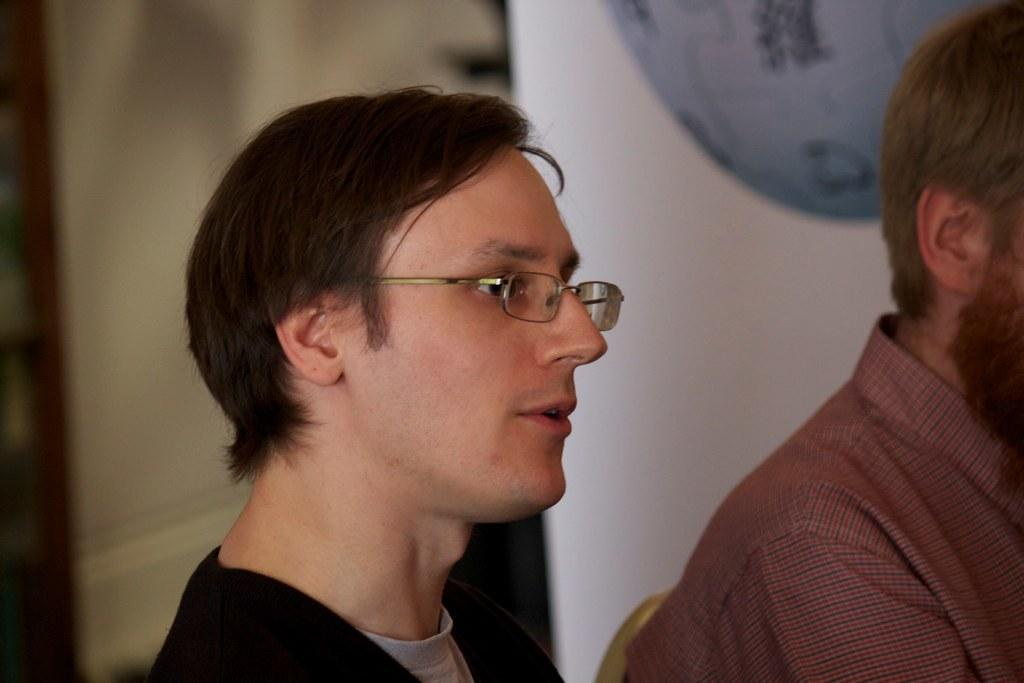How many people are in the image? There are two persons in the image. What are the persons doing in the image? The persons are sitting on a chair. What can be seen on the wall behind the persons? There is an object hanging on the wall behind the persons. Can you describe the other side of the image? The other side of the image is blurred. What type of cup is being used to serve the stew in the image? There is no cup or stew present in the image. 